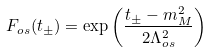Convert formula to latex. <formula><loc_0><loc_0><loc_500><loc_500>F _ { o s } ( t _ { \pm } ) = \exp \left ( \frac { t _ { \pm } - m _ { M } ^ { 2 } } { 2 \Lambda _ { o s } ^ { 2 } } \right )</formula> 